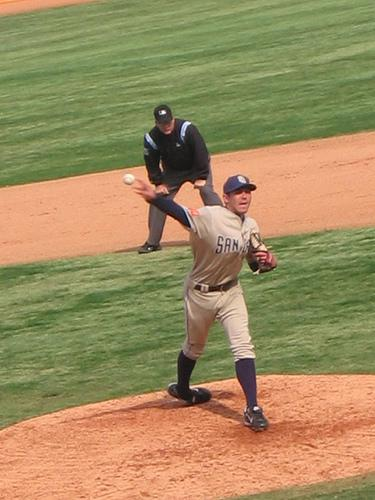Question: what is the pitcher wearing on his left hand?
Choices:
A. Ring.
B. Glove.
C. Baseball mitt.
D. Tattoos.
Answer with the letter. Answer: C Question: what color is the man's hat?
Choices:
A. Black.
B. Red.
C. Blue.
D. Grey.
Answer with the letter. Answer: C Question: what team does the man play for?
Choices:
A. The Jazz.
B. The Cardinals.
C. The Steelers.
D. The Padres.
Answer with the letter. Answer: D Question: what city does the man play for?
Choices:
A. Baltimore.
B. San Diego.
C. Jackson.
D. Denver.
Answer with the letter. Answer: B Question: where was this photographed?
Choices:
A. Park.
B. Baseball field.
C. Beach.
D. Skyscrapers.
Answer with the letter. Answer: B 